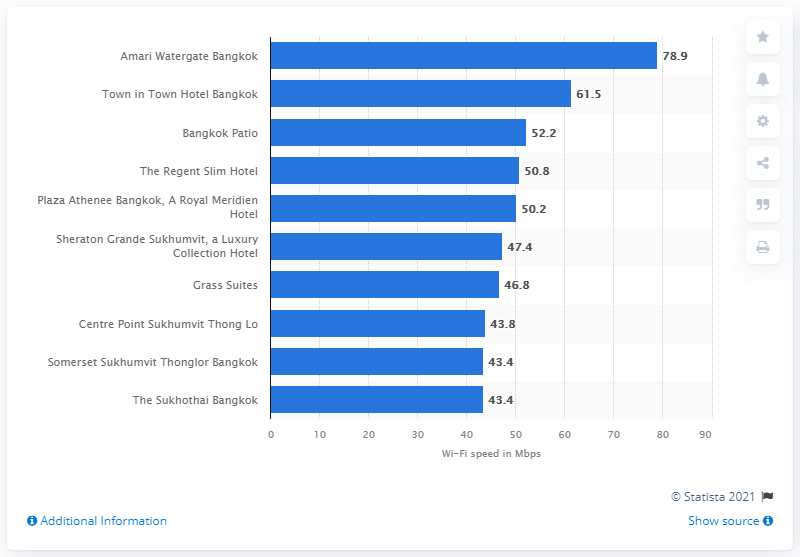List a handful of essential elements in this visual. In 2021, Amari Watergate Bangkok was recognized as the hotel with the fastest Wi-Fi speed. 